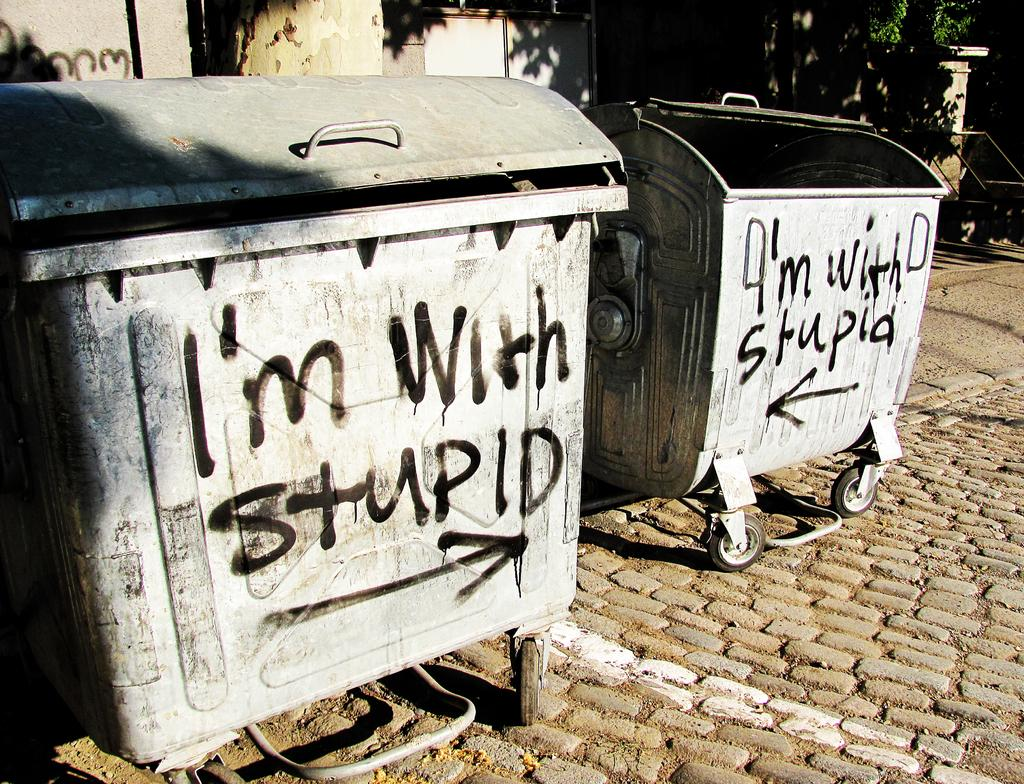<image>
Summarize the visual content of the image. A container is sprayed painted in black that reads, "I'm with stupid." 